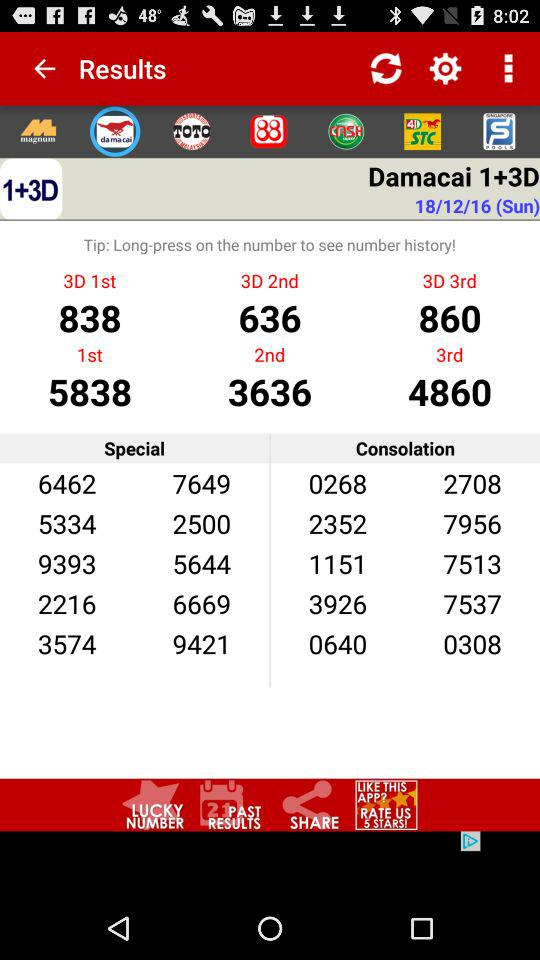What’s the date of "Damacai 1+3D"? The date is Sunday, December 18, 2016. 